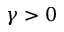<formula> <loc_0><loc_0><loc_500><loc_500>\gamma > 0</formula> 